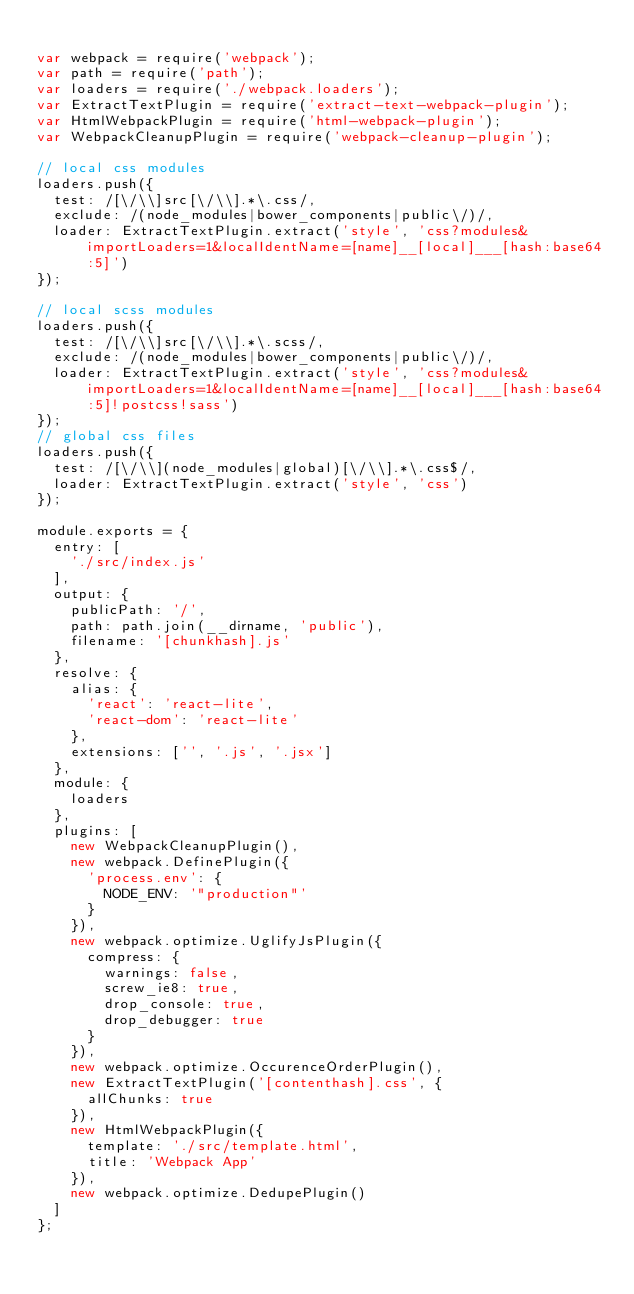<code> <loc_0><loc_0><loc_500><loc_500><_JavaScript_>
var webpack = require('webpack');
var path = require('path');
var loaders = require('./webpack.loaders');
var ExtractTextPlugin = require('extract-text-webpack-plugin');
var HtmlWebpackPlugin = require('html-webpack-plugin');
var WebpackCleanupPlugin = require('webpack-cleanup-plugin');

// local css modules
loaders.push({
	test: /[\/\\]src[\/\\].*\.css/,
	exclude: /(node_modules|bower_components|public\/)/,
	loader: ExtractTextPlugin.extract('style', 'css?modules&importLoaders=1&localIdentName=[name]__[local]___[hash:base64:5]')
});

// local scss modules
loaders.push({
	test: /[\/\\]src[\/\\].*\.scss/,
	exclude: /(node_modules|bower_components|public\/)/,
	loader: ExtractTextPlugin.extract('style', 'css?modules&importLoaders=1&localIdentName=[name]__[local]___[hash:base64:5]!postcss!sass')
});
// global css files
loaders.push({
	test: /[\/\\](node_modules|global)[\/\\].*\.css$/,
	loader: ExtractTextPlugin.extract('style', 'css')
});

module.exports = {
	entry: [
		'./src/index.js'
	],
	output: {
		publicPath: '/',
		path: path.join(__dirname, 'public'),
		filename: '[chunkhash].js'
	},
	resolve: {
	  alias: {
	    'react': 'react-lite',
	    'react-dom': 'react-lite'
	  },
		extensions: ['', '.js', '.jsx']
	},
	module: {
		loaders
	},
	plugins: [
		new WebpackCleanupPlugin(),
		new webpack.DefinePlugin({
			'process.env': {
				NODE_ENV: '"production"'
			}
		}),
		new webpack.optimize.UglifyJsPlugin({
			compress: {
				warnings: false,
				screw_ie8: true,
				drop_console: true,
				drop_debugger: true
			}
		}),
		new webpack.optimize.OccurenceOrderPlugin(),
		new ExtractTextPlugin('[contenthash].css', {
			allChunks: true
		}),
		new HtmlWebpackPlugin({
			template: './src/template.html',
			title: 'Webpack App'
		}),
		new webpack.optimize.DedupePlugin()
	]
};
</code> 